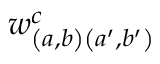Convert formula to latex. <formula><loc_0><loc_0><loc_500><loc_500>w _ { \left ( a , b \right ) \left ( a ^ { \prime } , b ^ { \prime } \right ) } ^ { c }</formula> 